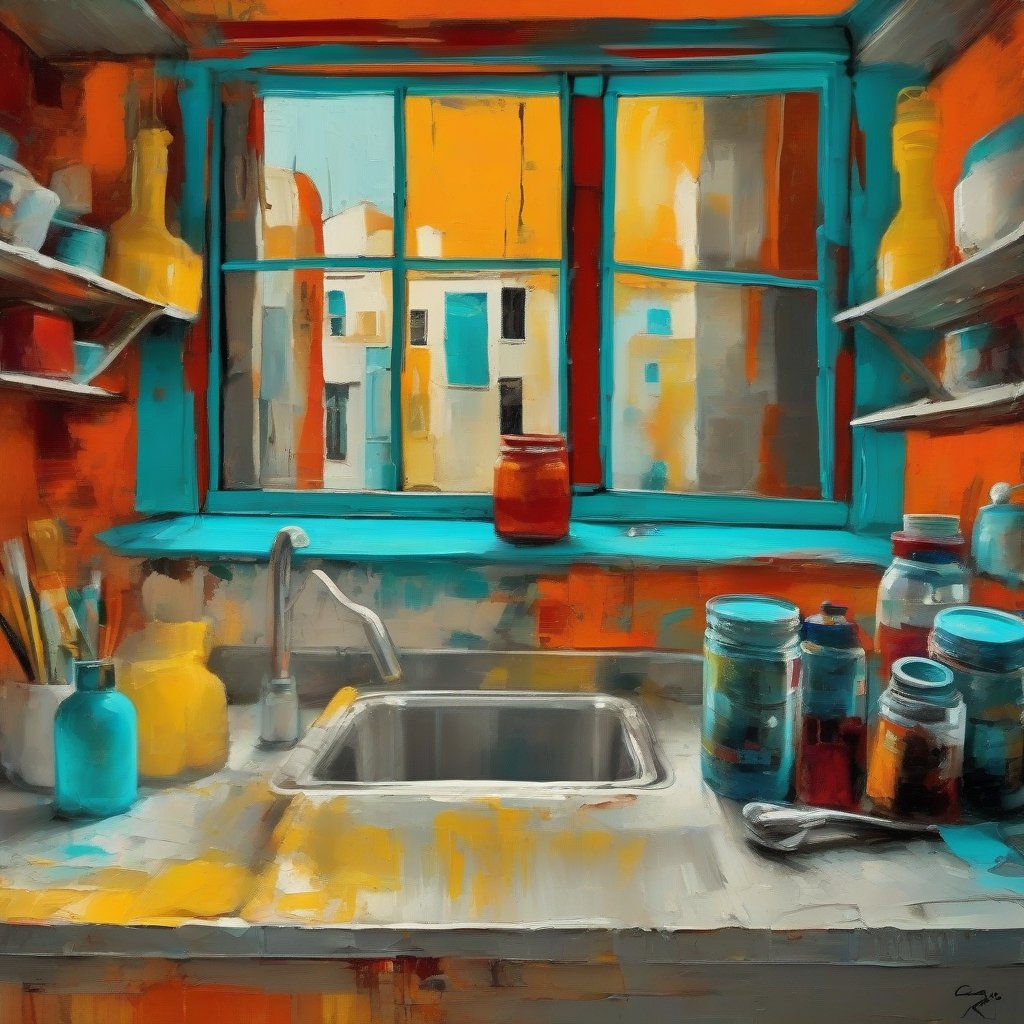describe the image in artistic terms The painting is a colorful depiction of a kitchen window. The window is painted in a bright blue color, and the walls are painted in a warm orange color. The window is open, and there is a view of a cityscape outside. There are several objects on the windowsill, including a vase, a pitcher, and some books. The painting is done in a loose, impressionistic style, and the colors are vibrant and expressive. The painting has a cheerful and inviting atmosphere, and it captures the beauty of a simple moment in everyday life. 